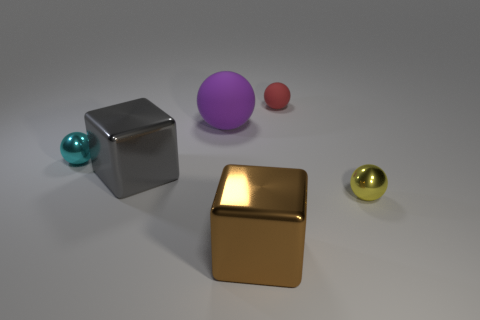There is a object that is left of the red object and to the right of the purple rubber thing; how big is it?
Provide a short and direct response. Large. There is a rubber sphere to the left of the brown shiny cube; does it have the same color as the tiny matte sphere?
Provide a succinct answer. No. Is the number of gray things in front of the brown metal block less than the number of purple objects?
Ensure brevity in your answer.  Yes. The other thing that is made of the same material as the large purple thing is what shape?
Offer a terse response. Sphere. Does the gray cube have the same material as the tiny red ball?
Offer a very short reply. No. Are there fewer red matte things that are in front of the gray shiny thing than tiny metal balls that are to the right of the big brown shiny block?
Your response must be concise. Yes. There is a small metallic ball left of the small shiny object to the right of the big brown object; what number of balls are to the left of it?
Offer a terse response. 0. Is the tiny rubber sphere the same color as the large matte thing?
Provide a succinct answer. No. Is there a small shiny ball of the same color as the tiny matte thing?
Offer a terse response. No. There is a matte ball that is the same size as the cyan shiny thing; what color is it?
Provide a short and direct response. Red. 